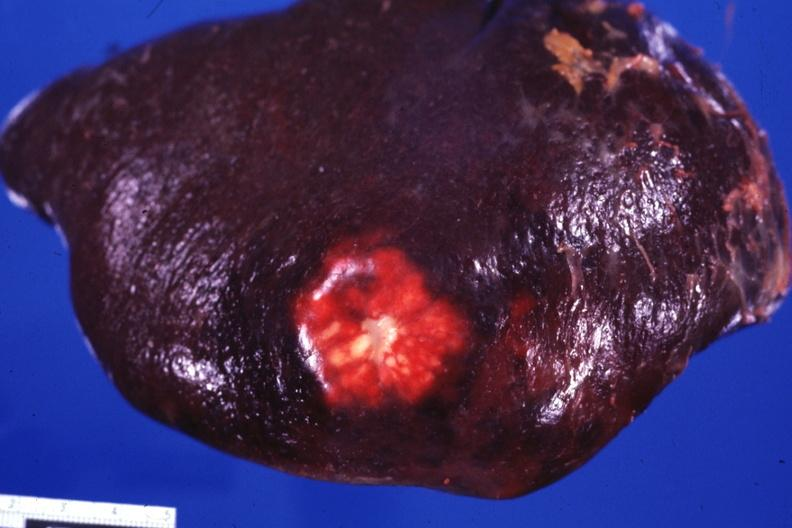what is present?
Answer the question using a single word or phrase. Metastatic carcinoma colon 